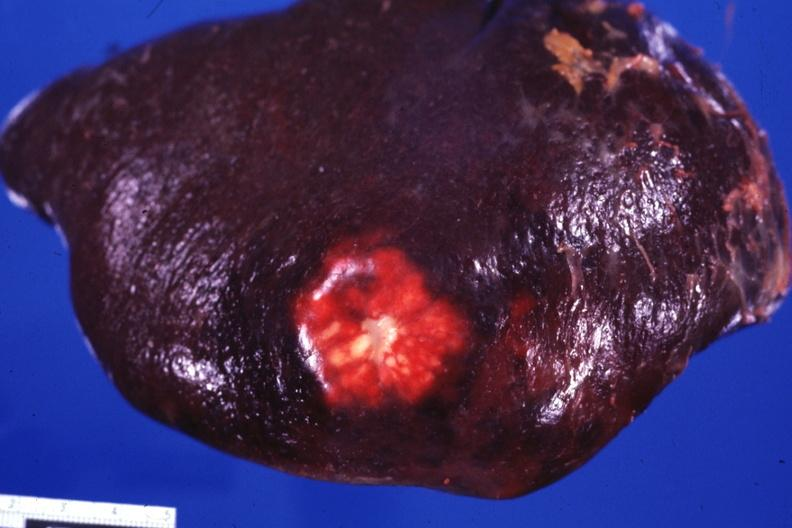what is present?
Answer the question using a single word or phrase. Metastatic carcinoma colon 